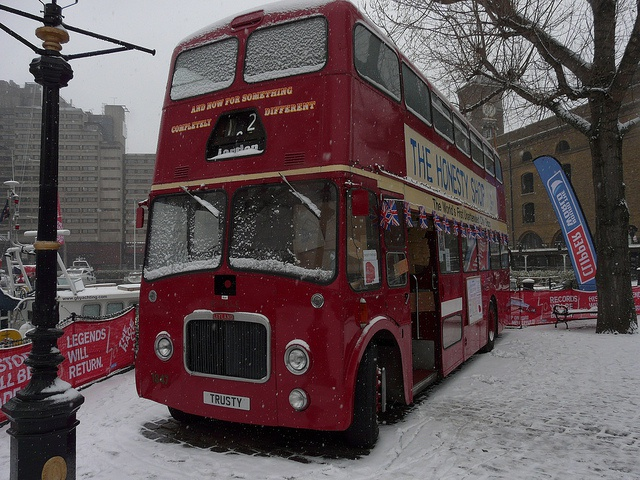Describe the objects in this image and their specific colors. I can see bus in darkgray, maroon, black, and gray tones, boat in darkgray, gray, black, and lightgray tones, and bus in darkgray, black, and gray tones in this image. 